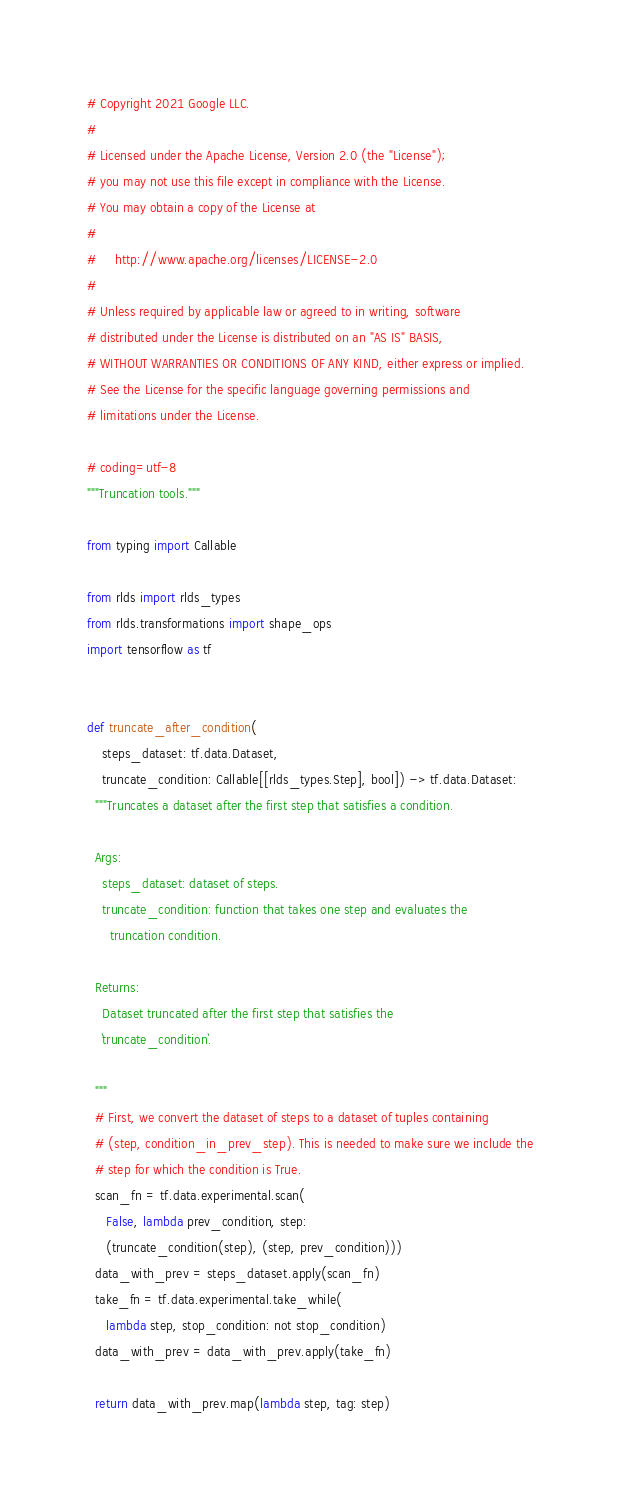<code> <loc_0><loc_0><loc_500><loc_500><_Python_># Copyright 2021 Google LLC.
#
# Licensed under the Apache License, Version 2.0 (the "License");
# you may not use this file except in compliance with the License.
# You may obtain a copy of the License at
#
#     http://www.apache.org/licenses/LICENSE-2.0
#
# Unless required by applicable law or agreed to in writing, software
# distributed under the License is distributed on an "AS IS" BASIS,
# WITHOUT WARRANTIES OR CONDITIONS OF ANY KIND, either express or implied.
# See the License for the specific language governing permissions and
# limitations under the License.

# coding=utf-8
"""Truncation tools."""

from typing import Callable

from rlds import rlds_types
from rlds.transformations import shape_ops
import tensorflow as tf


def truncate_after_condition(
    steps_dataset: tf.data.Dataset,
    truncate_condition: Callable[[rlds_types.Step], bool]) -> tf.data.Dataset:
  """Truncates a dataset after the first step that satisfies a condition.

  Args:
    steps_dataset: dataset of steps.
    truncate_condition: function that takes one step and evaluates the
      truncation condition.

  Returns:
    Dataset truncated after the first step that satisfies the
    `truncate_condition`.

  """
  # First, we convert the dataset of steps to a dataset of tuples containing
  # (step, condition_in_prev_step). This is needed to make sure we include the
  # step for which the condition is True.
  scan_fn = tf.data.experimental.scan(
     False, lambda prev_condition, step:
     (truncate_condition(step), (step, prev_condition)))
  data_with_prev = steps_dataset.apply(scan_fn)
  take_fn = tf.data.experimental.take_while(
     lambda step, stop_condition: not stop_condition)
  data_with_prev = data_with_prev.apply(take_fn)

  return data_with_prev.map(lambda step, tag: step)


</code> 